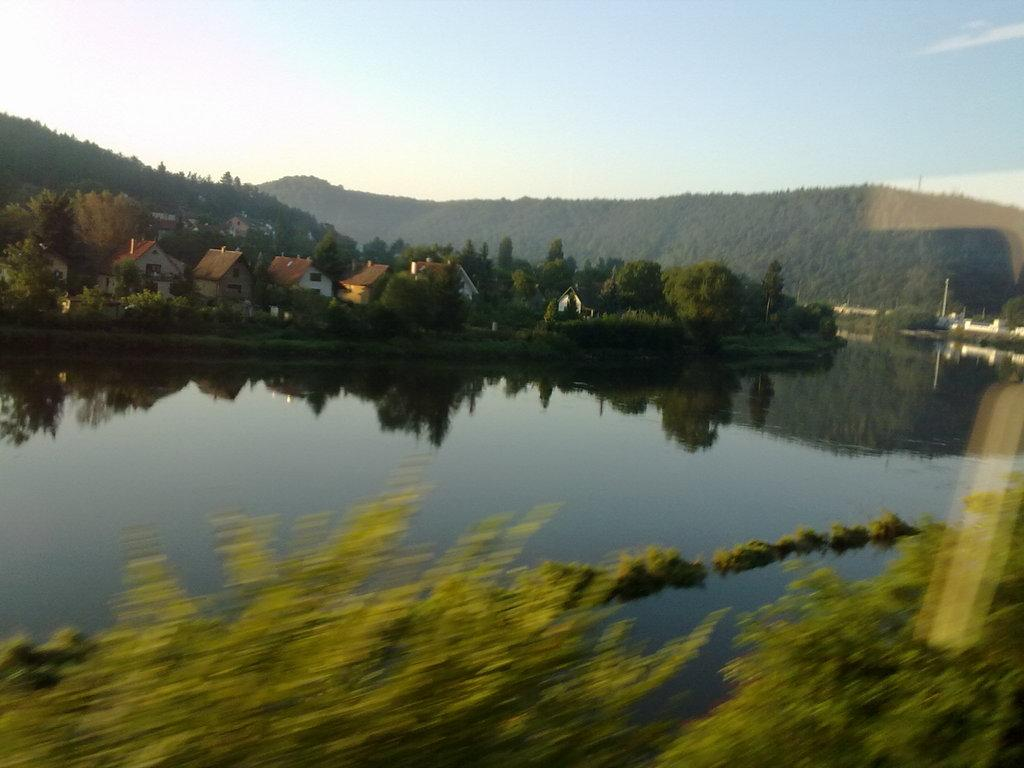What is the primary element in the image? There is water in the image. What can be seen near the water? There are plants near the water. What type of vegetation is visible in the image? Trees are visible in the image. What type of structures are present in the image? Houses are present in the image. What is visible in the background of the image? The sky is visible in the image. Can you tell me how many apples are floating in the water in the image? There are no apples present in the image; it features water, plants, trees, houses, and the sky. Does the existence of the water in the image prove the existence of other dimensions? The presence of water in the image does not prove the existence of other dimensions; it is simply a natural element in the scene. 